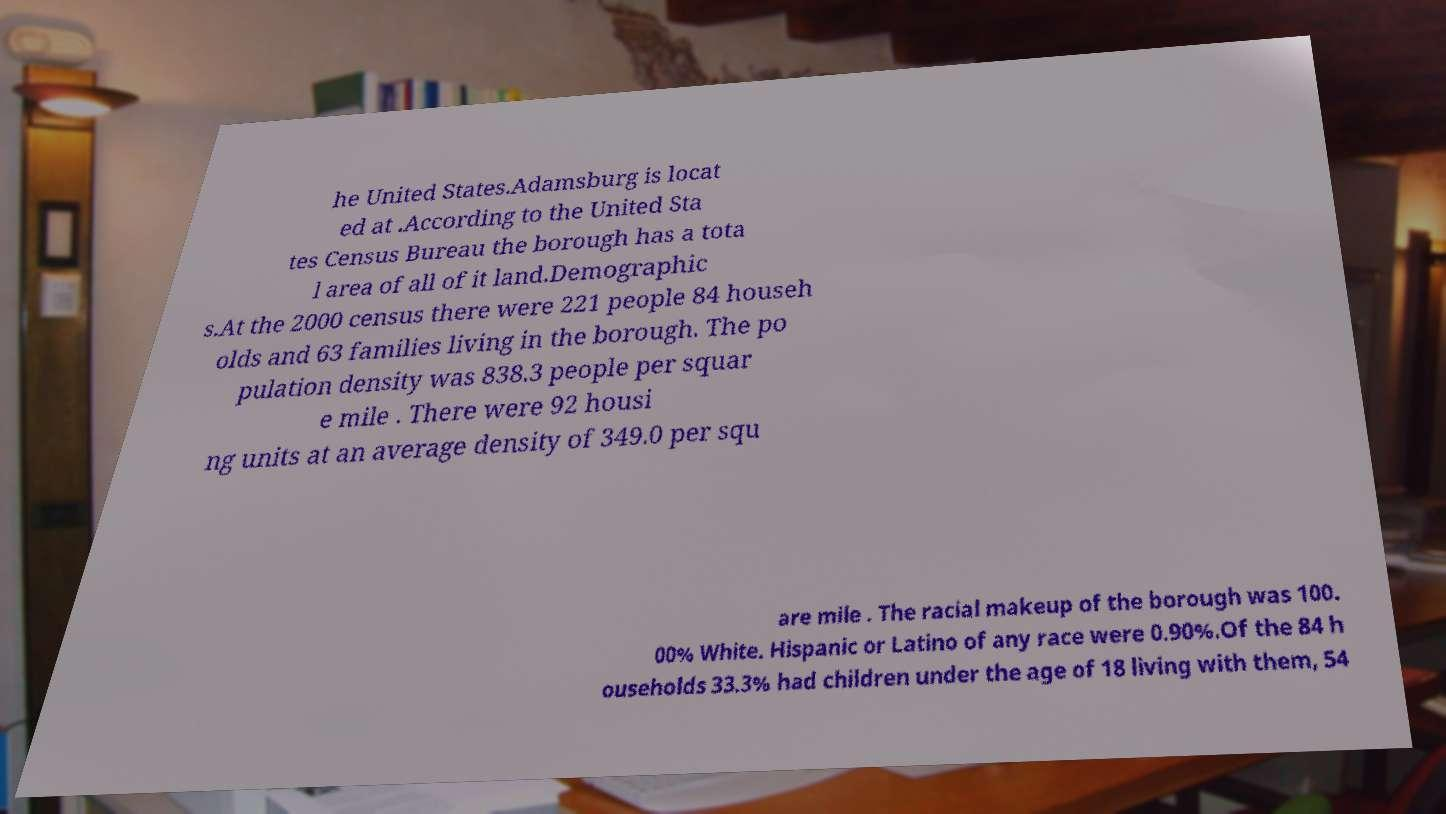Could you extract and type out the text from this image? he United States.Adamsburg is locat ed at .According to the United Sta tes Census Bureau the borough has a tota l area of all of it land.Demographic s.At the 2000 census there were 221 people 84 househ olds and 63 families living in the borough. The po pulation density was 838.3 people per squar e mile . There were 92 housi ng units at an average density of 349.0 per squ are mile . The racial makeup of the borough was 100. 00% White. Hispanic or Latino of any race were 0.90%.Of the 84 h ouseholds 33.3% had children under the age of 18 living with them, 54 